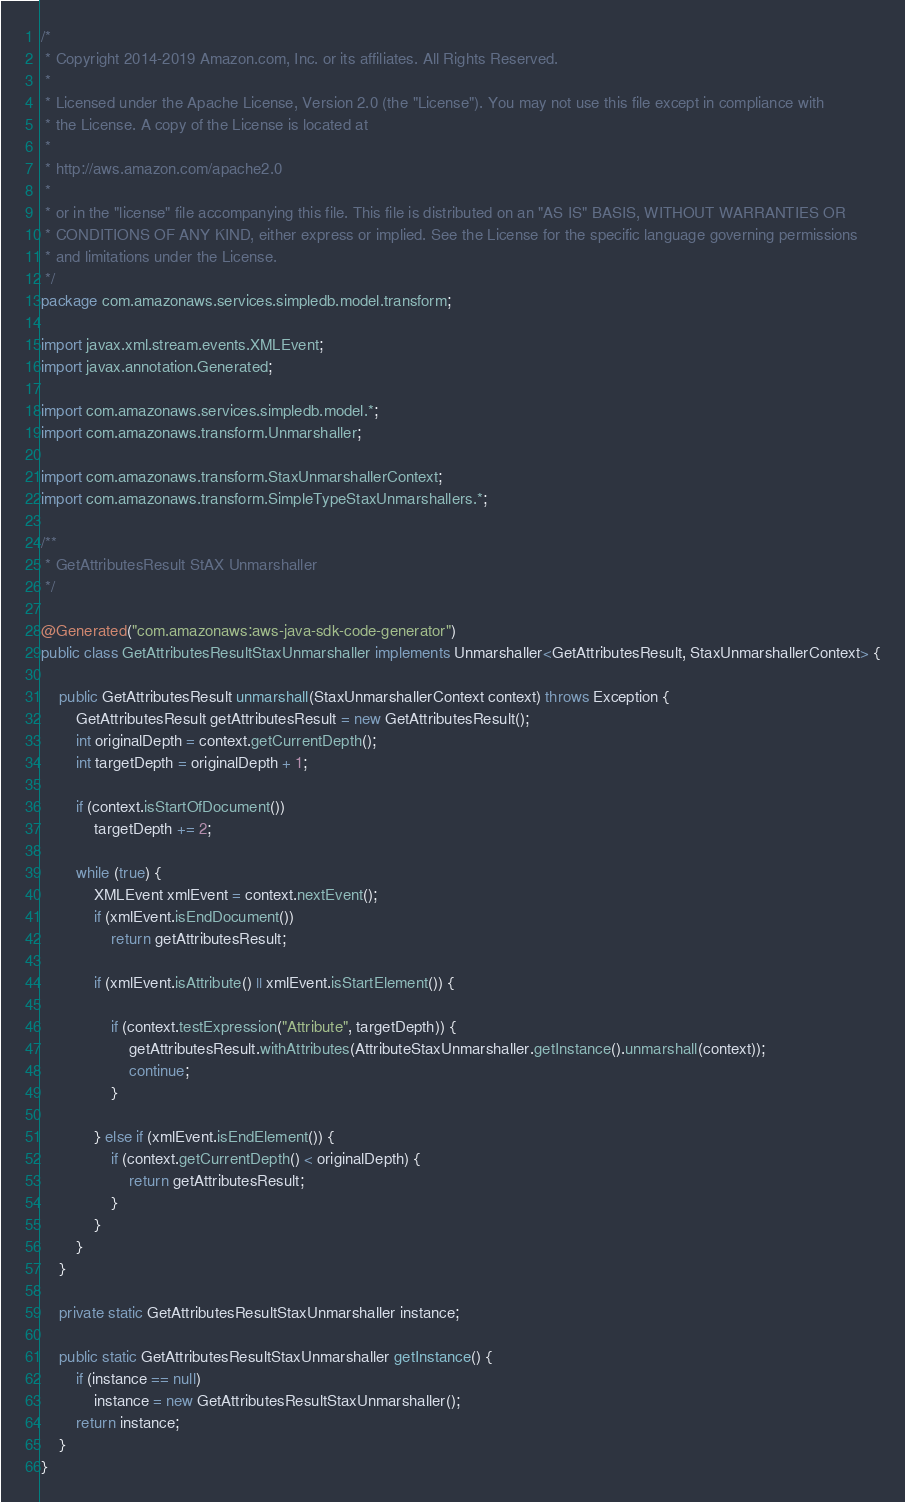<code> <loc_0><loc_0><loc_500><loc_500><_Java_>/*
 * Copyright 2014-2019 Amazon.com, Inc. or its affiliates. All Rights Reserved.
 * 
 * Licensed under the Apache License, Version 2.0 (the "License"). You may not use this file except in compliance with
 * the License. A copy of the License is located at
 * 
 * http://aws.amazon.com/apache2.0
 * 
 * or in the "license" file accompanying this file. This file is distributed on an "AS IS" BASIS, WITHOUT WARRANTIES OR
 * CONDITIONS OF ANY KIND, either express or implied. See the License for the specific language governing permissions
 * and limitations under the License.
 */
package com.amazonaws.services.simpledb.model.transform;

import javax.xml.stream.events.XMLEvent;
import javax.annotation.Generated;

import com.amazonaws.services.simpledb.model.*;
import com.amazonaws.transform.Unmarshaller;

import com.amazonaws.transform.StaxUnmarshallerContext;
import com.amazonaws.transform.SimpleTypeStaxUnmarshallers.*;

/**
 * GetAttributesResult StAX Unmarshaller
 */

@Generated("com.amazonaws:aws-java-sdk-code-generator")
public class GetAttributesResultStaxUnmarshaller implements Unmarshaller<GetAttributesResult, StaxUnmarshallerContext> {

    public GetAttributesResult unmarshall(StaxUnmarshallerContext context) throws Exception {
        GetAttributesResult getAttributesResult = new GetAttributesResult();
        int originalDepth = context.getCurrentDepth();
        int targetDepth = originalDepth + 1;

        if (context.isStartOfDocument())
            targetDepth += 2;

        while (true) {
            XMLEvent xmlEvent = context.nextEvent();
            if (xmlEvent.isEndDocument())
                return getAttributesResult;

            if (xmlEvent.isAttribute() || xmlEvent.isStartElement()) {

                if (context.testExpression("Attribute", targetDepth)) {
                    getAttributesResult.withAttributes(AttributeStaxUnmarshaller.getInstance().unmarshall(context));
                    continue;
                }

            } else if (xmlEvent.isEndElement()) {
                if (context.getCurrentDepth() < originalDepth) {
                    return getAttributesResult;
                }
            }
        }
    }

    private static GetAttributesResultStaxUnmarshaller instance;

    public static GetAttributesResultStaxUnmarshaller getInstance() {
        if (instance == null)
            instance = new GetAttributesResultStaxUnmarshaller();
        return instance;
    }
}
</code> 